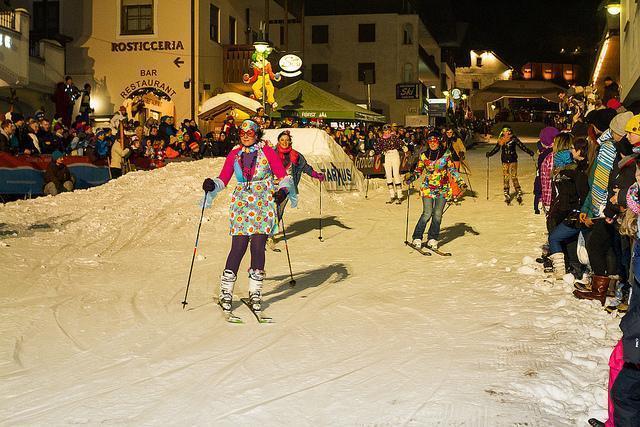How many people are visible?
Give a very brief answer. 4. 